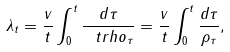<formula> <loc_0><loc_0><loc_500><loc_500>\lambda _ { t } = \frac { v } { t } \real \int _ { 0 } ^ { t } \frac { d \tau } { \ t r h o _ { \tau } } = \frac { v } { t } \int _ { 0 } ^ { t } \frac { d \tau } { \rho _ { \tau } } ,</formula> 